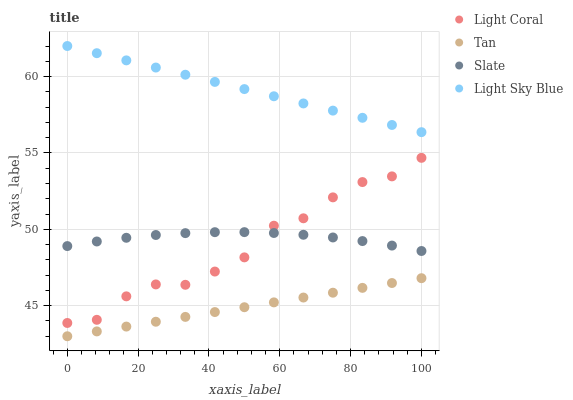Does Tan have the minimum area under the curve?
Answer yes or no. Yes. Does Light Sky Blue have the maximum area under the curve?
Answer yes or no. Yes. Does Light Sky Blue have the minimum area under the curve?
Answer yes or no. No. Does Tan have the maximum area under the curve?
Answer yes or no. No. Is Tan the smoothest?
Answer yes or no. Yes. Is Light Coral the roughest?
Answer yes or no. Yes. Is Light Sky Blue the smoothest?
Answer yes or no. No. Is Light Sky Blue the roughest?
Answer yes or no. No. Does Tan have the lowest value?
Answer yes or no. Yes. Does Light Sky Blue have the lowest value?
Answer yes or no. No. Does Light Sky Blue have the highest value?
Answer yes or no. Yes. Does Tan have the highest value?
Answer yes or no. No. Is Tan less than Light Sky Blue?
Answer yes or no. Yes. Is Light Coral greater than Tan?
Answer yes or no. Yes. Does Slate intersect Light Coral?
Answer yes or no. Yes. Is Slate less than Light Coral?
Answer yes or no. No. Is Slate greater than Light Coral?
Answer yes or no. No. Does Tan intersect Light Sky Blue?
Answer yes or no. No. 